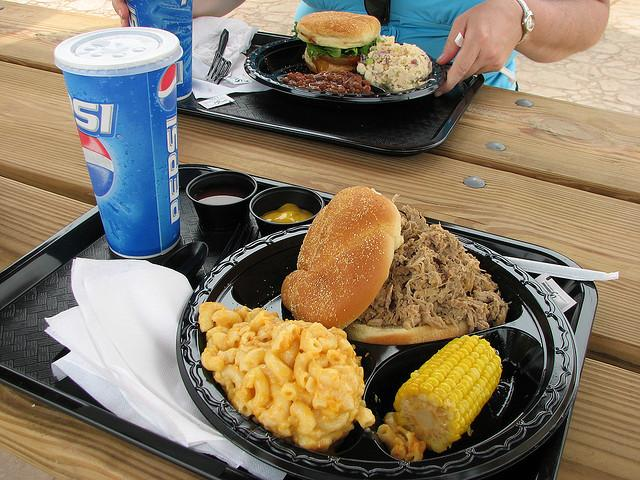Which item on the plate is highest in carbs if the person ate all of it? macaroni 